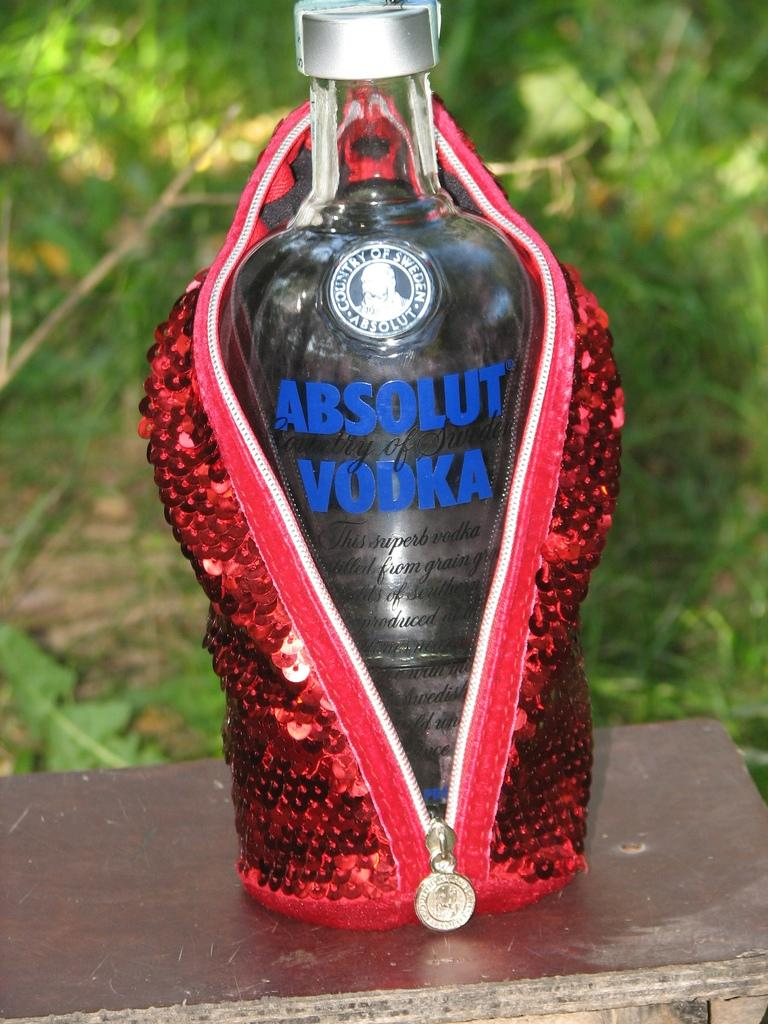What is the main object in the picture? There is a vodka bottle in the picture. How is the vodka bottle being stored or protected? The vodka bottle is packed in a zipper bag. Where is the vodka bottle placed? The vodka bottle is kept on a table. What can be seen in the background of the image? There is grass visible in the background of the image. Is there a feast happening in the image, and can you see any feathers? There is no feast or feathers present in the image; it only features a vodka bottle packed in a zipper bag and placed on a table, with grass visible in the background. 